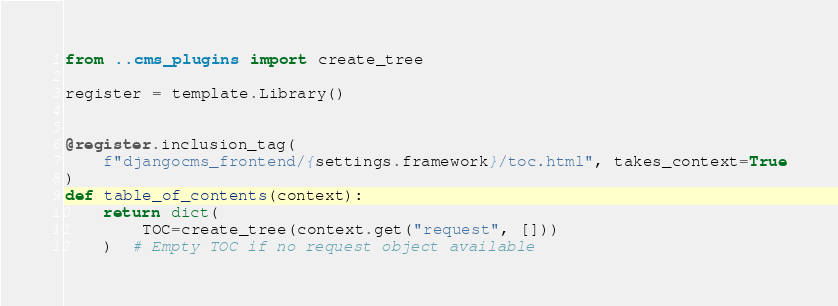<code> <loc_0><loc_0><loc_500><loc_500><_Python_>from ..cms_plugins import create_tree

register = template.Library()


@register.inclusion_tag(
    f"djangocms_frontend/{settings.framework}/toc.html", takes_context=True
)
def table_of_contents(context):
    return dict(
        TOC=create_tree(context.get("request", []))
    )  # Empty TOC if no request object available
</code> 